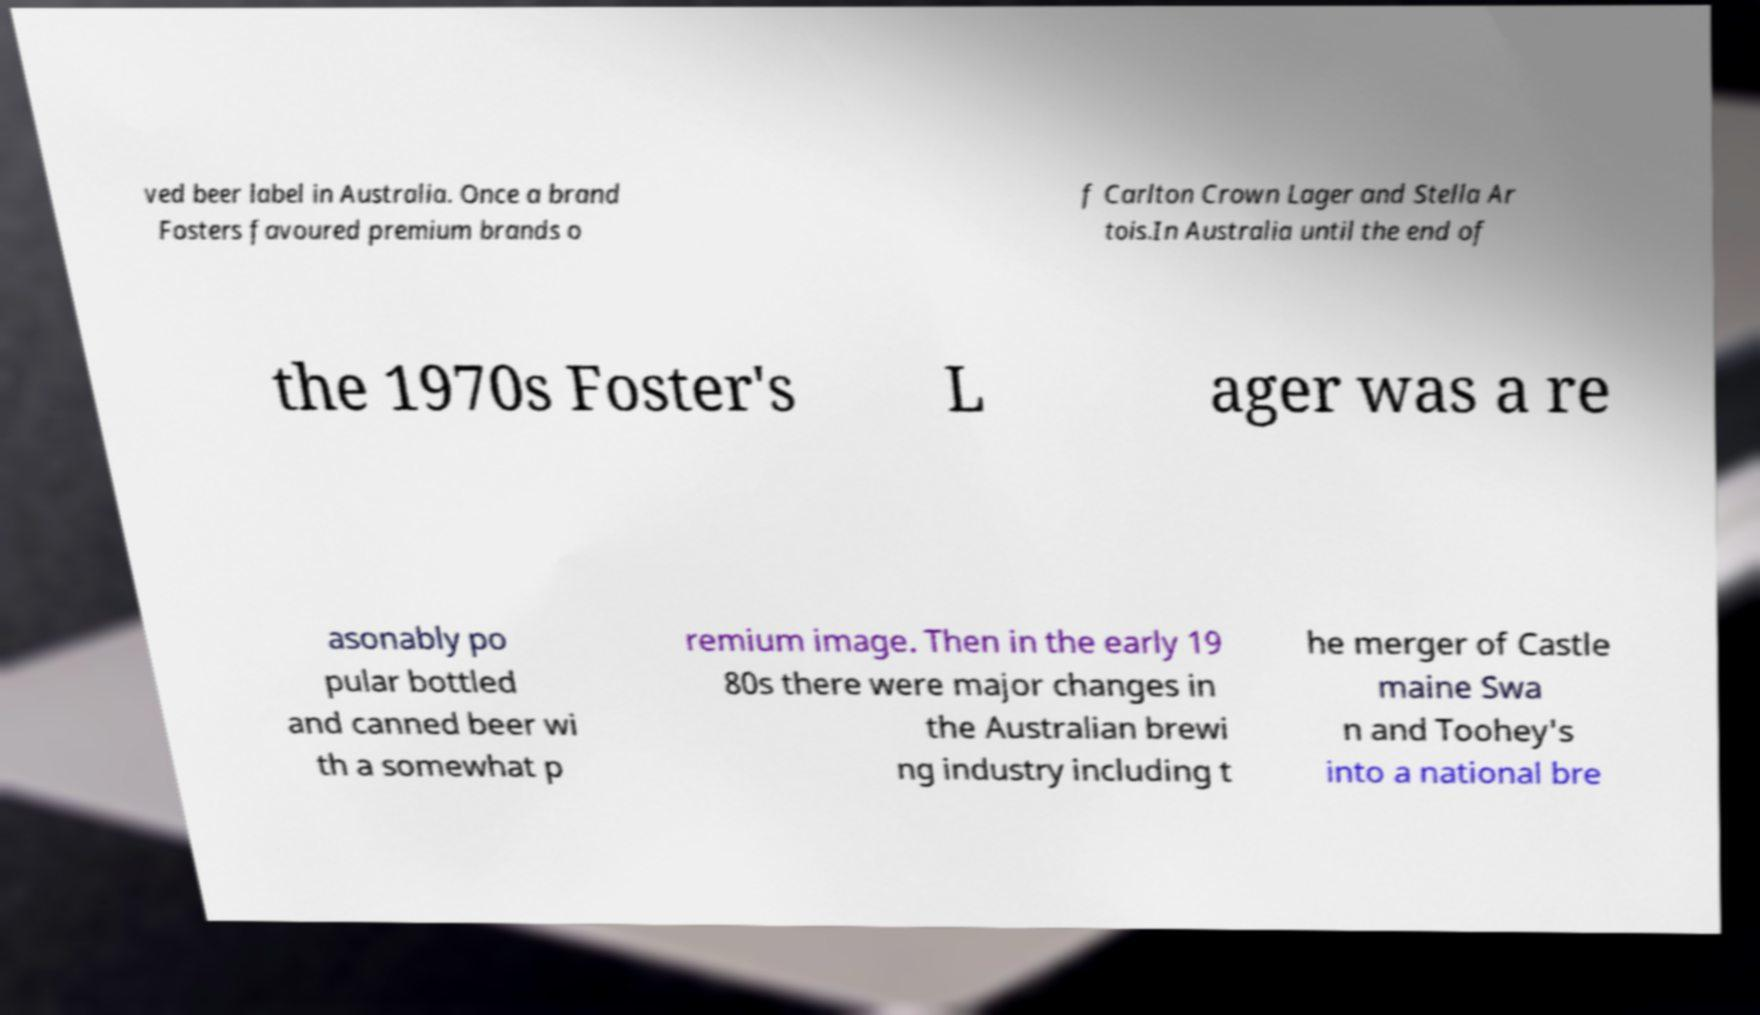Can you read and provide the text displayed in the image?This photo seems to have some interesting text. Can you extract and type it out for me? ved beer label in Australia. Once a brand Fosters favoured premium brands o f Carlton Crown Lager and Stella Ar tois.In Australia until the end of the 1970s Foster's L ager was a re asonably po pular bottled and canned beer wi th a somewhat p remium image. Then in the early 19 80s there were major changes in the Australian brewi ng industry including t he merger of Castle maine Swa n and Toohey's into a national bre 